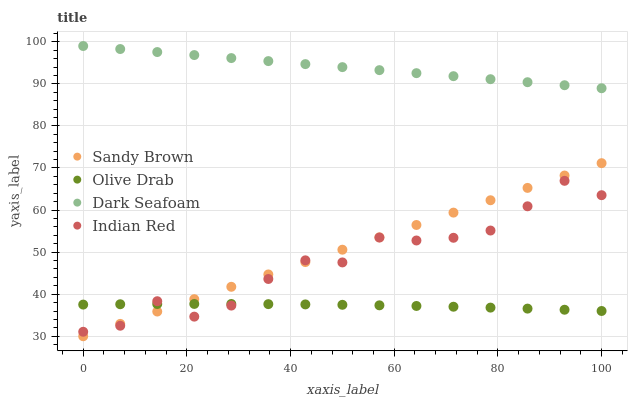Does Olive Drab have the minimum area under the curve?
Answer yes or no. Yes. Does Dark Seafoam have the maximum area under the curve?
Answer yes or no. Yes. Does Sandy Brown have the minimum area under the curve?
Answer yes or no. No. Does Sandy Brown have the maximum area under the curve?
Answer yes or no. No. Is Sandy Brown the smoothest?
Answer yes or no. Yes. Is Indian Red the roughest?
Answer yes or no. Yes. Is Indian Red the smoothest?
Answer yes or no. No. Is Sandy Brown the roughest?
Answer yes or no. No. Does Sandy Brown have the lowest value?
Answer yes or no. Yes. Does Indian Red have the lowest value?
Answer yes or no. No. Does Dark Seafoam have the highest value?
Answer yes or no. Yes. Does Sandy Brown have the highest value?
Answer yes or no. No. Is Indian Red less than Dark Seafoam?
Answer yes or no. Yes. Is Dark Seafoam greater than Sandy Brown?
Answer yes or no. Yes. Does Olive Drab intersect Sandy Brown?
Answer yes or no. Yes. Is Olive Drab less than Sandy Brown?
Answer yes or no. No. Is Olive Drab greater than Sandy Brown?
Answer yes or no. No. Does Indian Red intersect Dark Seafoam?
Answer yes or no. No. 